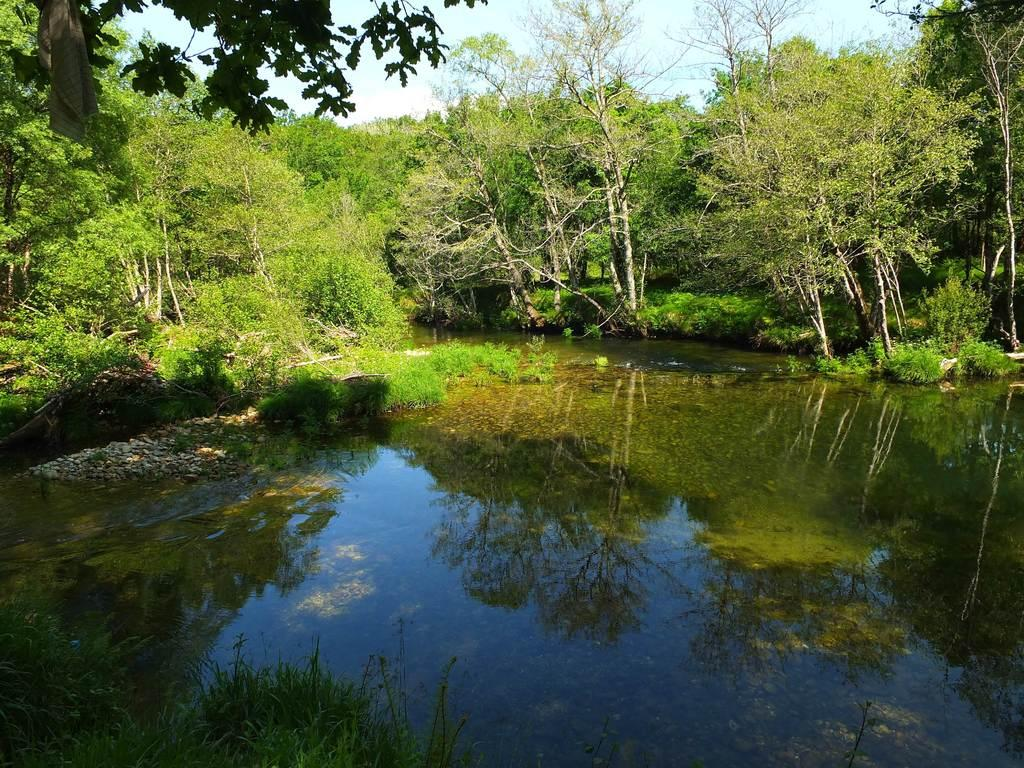What type of vegetation can be seen in the image? There are many trees, plants, and grass visible in the image. What is at the bottom of the image? There is water visible at the bottom of the image. What is visible at the top of the image? The sky is visible at the top of the image. What can be seen in the sky? Clouds are present in the sky. What type of fork can be seen in the image? There is no fork present in the image. What news is being reported in the image? There is no news or any indication of reporting in the image. 